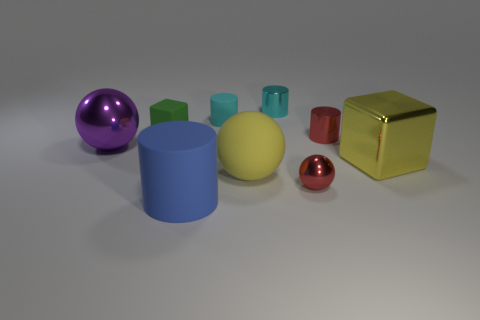Subtract all tiny cylinders. How many cylinders are left? 1 Add 1 big objects. How many objects exist? 10 Subtract all cyan cylinders. How many cylinders are left? 2 Subtract 2 cubes. How many cubes are left? 0 Subtract all small cylinders. Subtract all big yellow blocks. How many objects are left? 5 Add 7 large yellow cubes. How many large yellow cubes are left? 8 Add 1 tiny red objects. How many tiny red objects exist? 3 Subtract 1 yellow cubes. How many objects are left? 8 Subtract all spheres. How many objects are left? 6 Subtract all gray spheres. Subtract all gray blocks. How many spheres are left? 3 